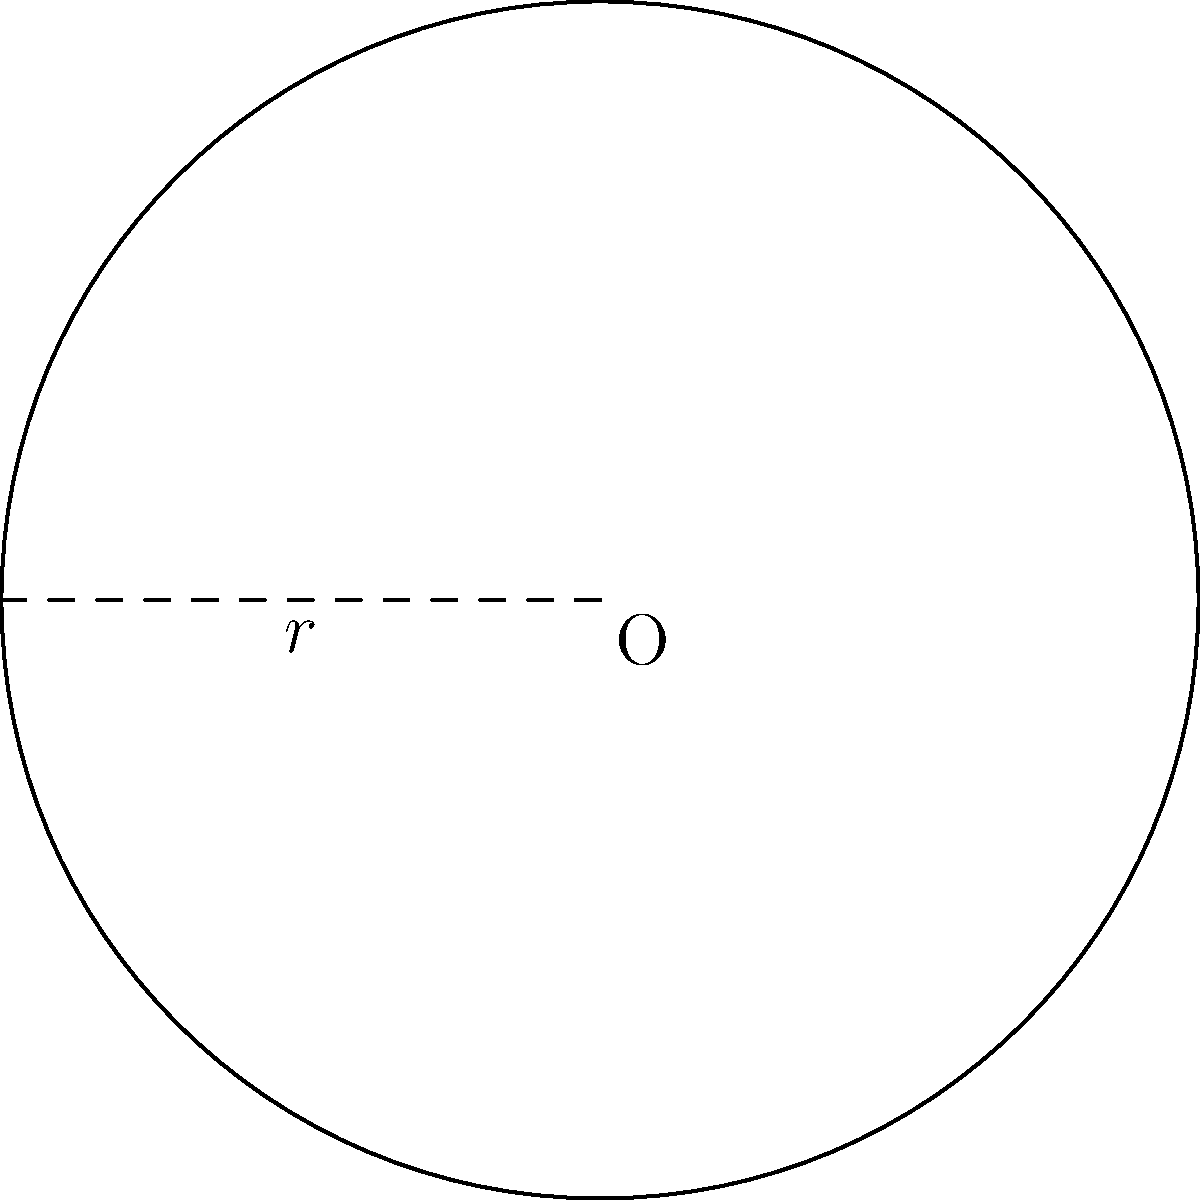As a physician funding low-profit medical innovations, you're developing a new surgical technique that requires precise measurements. The circular surgical field has a radius of 5 cm. Calculate the area of this surgical field to determine the coverage of a new sterile drape. Use $\pi \approx 3.14$ for your calculations. To calculate the area of a circular surgical field, we use the formula for the area of a circle:

$$A = \pi r^2$$

Where:
$A$ = Area of the circle
$\pi$ ≈ 3.14 (given approximation)
$r$ = Radius of the circle

Given:
- Radius ($r$) = 5 cm
- $\pi \approx 3.14$

Step 1: Substitute the values into the formula.
$$A = \pi r^2 = 3.14 \times 5^2$$

Step 2: Calculate the square of the radius.
$$A = 3.14 \times 25$$

Step 3: Multiply to get the final area.
$$A = 78.5 \text{ cm}^2$$

Therefore, the area of the circular surgical field is approximately 78.5 square centimeters.
Answer: $78.5 \text{ cm}^2$ 